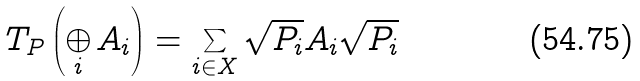<formula> <loc_0><loc_0><loc_500><loc_500>T _ { P } \left ( \bigoplus _ { i } A _ { i } \right ) = \sum _ { i \in X } \sqrt { P _ { i } } A _ { i } \sqrt { P _ { i } }</formula> 